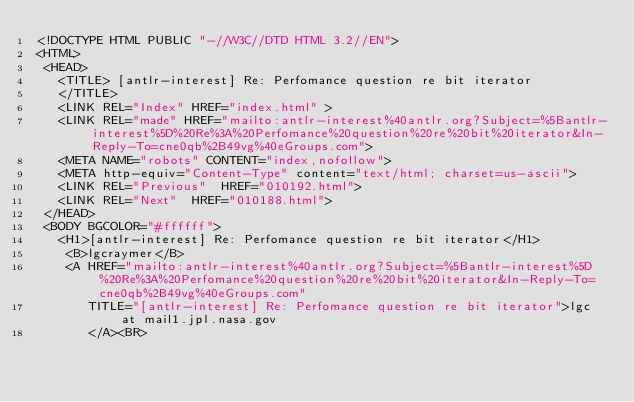Convert code to text. <code><loc_0><loc_0><loc_500><loc_500><_HTML_><!DOCTYPE HTML PUBLIC "-//W3C//DTD HTML 3.2//EN">
<HTML>
 <HEAD>
   <TITLE> [antlr-interest] Re: Perfomance question re bit iterator
   </TITLE>
   <LINK REL="Index" HREF="index.html" >
   <LINK REL="made" HREF="mailto:antlr-interest%40antlr.org?Subject=%5Bantlr-interest%5D%20Re%3A%20Perfomance%20question%20re%20bit%20iterator&In-Reply-To=cne0qb%2B49vg%40eGroups.com">
   <META NAME="robots" CONTENT="index,nofollow">
   <META http-equiv="Content-Type" content="text/html; charset=us-ascii">
   <LINK REL="Previous"  HREF="010192.html">
   <LINK REL="Next"  HREF="010188.html">
 </HEAD>
 <BODY BGCOLOR="#ffffff">
   <H1>[antlr-interest] Re: Perfomance question re bit iterator</H1>
    <B>lgcraymer</B> 
    <A HREF="mailto:antlr-interest%40antlr.org?Subject=%5Bantlr-interest%5D%20Re%3A%20Perfomance%20question%20re%20bit%20iterator&In-Reply-To=cne0qb%2B49vg%40eGroups.com"
       TITLE="[antlr-interest] Re: Perfomance question re bit iterator">lgc at mail1.jpl.nasa.gov
       </A><BR></code> 